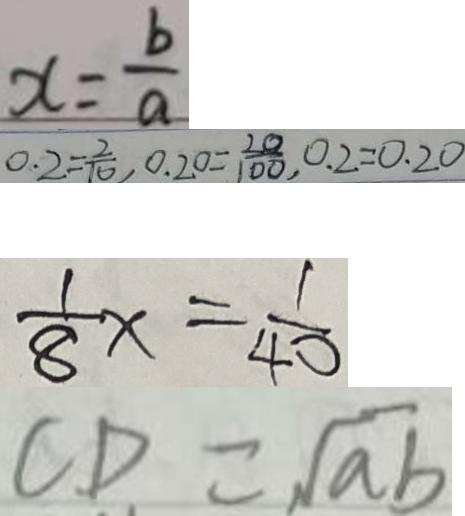Convert formula to latex. <formula><loc_0><loc_0><loc_500><loc_500>x = \frac { b } { a } 
 0 . 2 = \frac { 2 } { 1 0 } , 0 . 2 0 = \frac { 2 0 } { 1 0 0 } , 0 . 2 = 0 . 2 0 
 \frac { 1 } { 8 } x = \frac { 1 } { 4 0 } 
 C D = \sqrt { a b }</formula> 